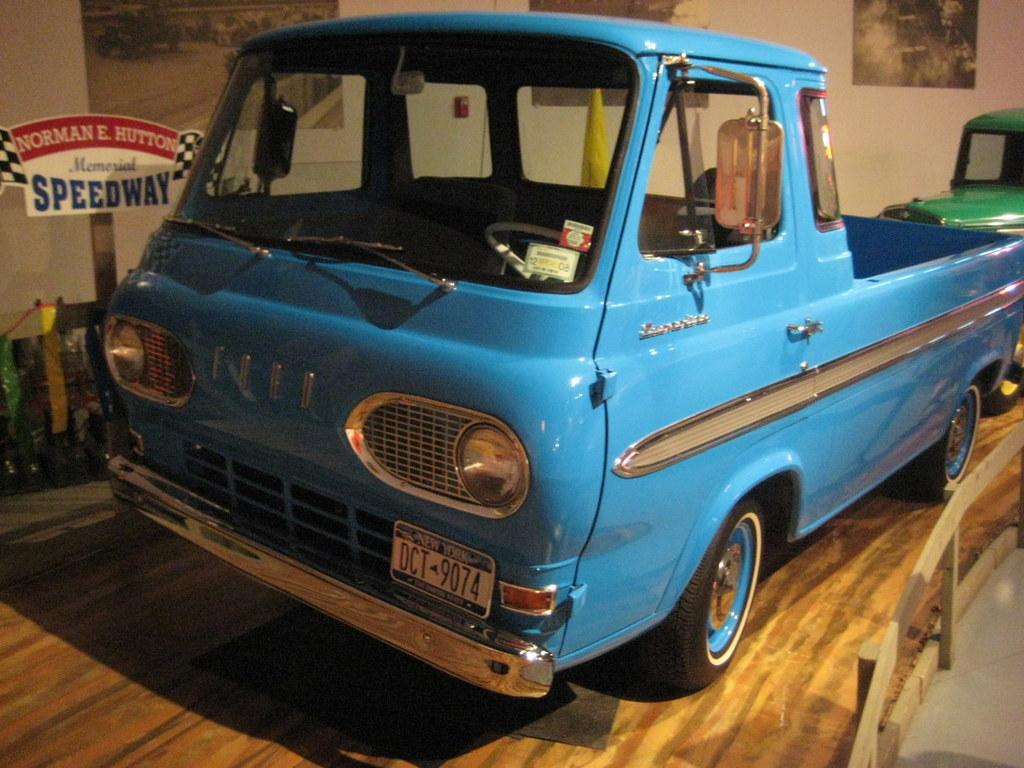What colors are the vehicles in the image? The vehicles in the image have blue and green colors. What type of barrier can be seen in the image? There is a wooden fence in the image. What object is present in the image that might be used for displaying information or messages? There is a board in the image. What is attached to the wall in the image? Papers are stick to the wall in the image. What grade did the person in the image receive for their performance? There is no person or performance mentioned in the image, so it is not possible to determine a grade. 